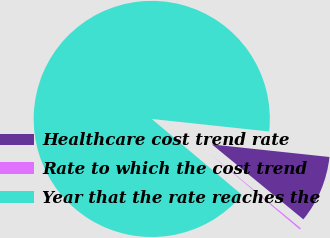<chart> <loc_0><loc_0><loc_500><loc_500><pie_chart><fcel>Healthcare cost trend rate<fcel>Rate to which the cost trend<fcel>Year that the rate reaches the<nl><fcel>9.24%<fcel>0.2%<fcel>90.56%<nl></chart> 